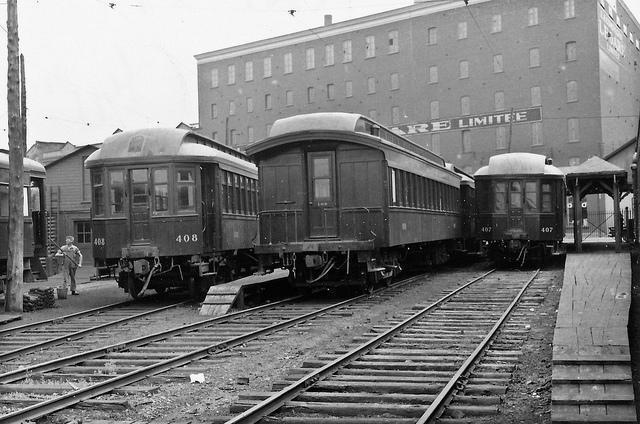What are the pants type the man is wearing?
From the following four choices, select the correct answer to address the question.
Options: Overalls, stonewashed jeans, slacks, khakis. Overalls. 